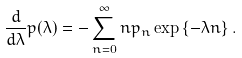Convert formula to latex. <formula><loc_0><loc_0><loc_500><loc_500>\frac { d } { d \lambda } p ( \lambda ) = - \sum _ { n = 0 } ^ { \infty } n p _ { n } \exp \left \{ - \lambda n \right \} .</formula> 